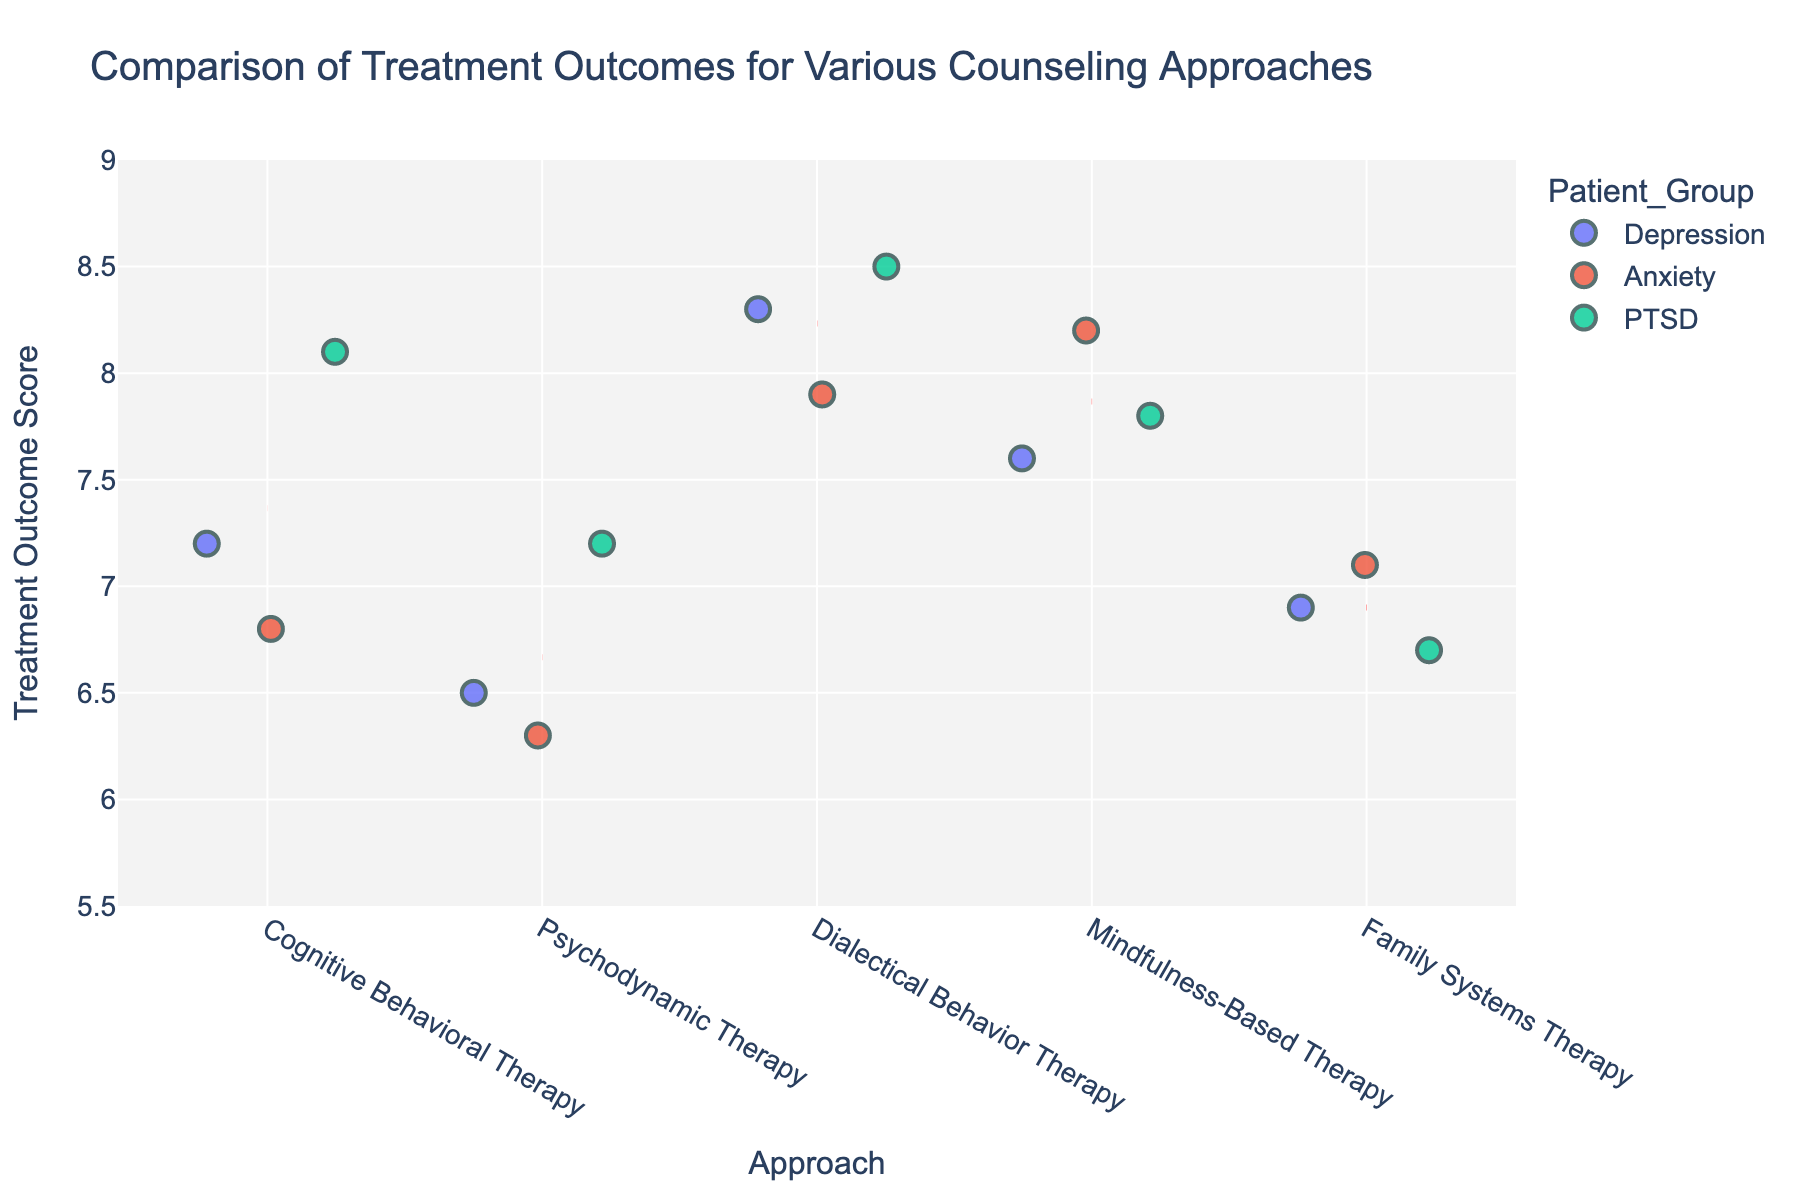What is the title of the figure? The title is shown at the top of the figure. It states the main theme or subject of the plot.
Answer: Comparison of Treatment Outcomes for Various Counseling Approaches How many different counseling approaches are compared in the figure? Each unique category on the x-axis (Approach) represents a different counseling approach.
Answer: 5 Which counseling approach has the highest treatment outcome score for PTSD patients? By looking at the y-axis values and filtering for PTSD (indicated by different colors), the highest point for PTSD aligns with Dialectical Behavior Therapy.
Answer: Dialectical Behavior Therapy What is the approximate average treatment outcome score for Cognitive Behavioral Therapy? To find the average, identify the scores for Cognitive Behavioral Therapy on the y-axis, then compute the mean: (7.2 + 6.8 + 8.1)/3.
Answer: 7.37 Which patient group generally shows the highest treatment outcome score across all approaches? By observing the placement of colors representing different patient groups along the y-axis, Anxiety scores are generally higher across multiple approaches.
Answer: Anxiety How does the average outcome score for Psychodynamic Therapy compare to Dialectical Behavior Therapy? Calculate the average for each approach: Psychodynamic Therapy (6.5, 6.3, 7.2) ≈ 6.67, Dialectical Behavior Therapy (8.3, 7.9, 8.5) ≈ 8.23. Compare their averages.
Answer: Dialectical Behavior Therapy has a higher average What is the range of treatment outcome scores for Family Systems Therapy? Identify the minimum and maximum points for Family Systems Therapy on the y-axis. The range is the difference between these values: max 7.1, min 6.7.
Answer: 6.7 to 7.1 Are there any counseling approaches where the mean outcome score is below 7? If so, which? Look for red dashed lines (mean scores) on the figure and assess which approach's mean score lies below 7. This comparison indicates that both Psychodynamic Therapy and Family Systems Therapy satisfy this condition.
Answer: Psychodynamic Therapy, Family Systems Therapy Which patient group has the lowest outcome score within any counseling approach? Pinpoint the lowest point across all patient groups on the y-axis and note the corresponding group and approach. The lowest score (6.3) belongs to Anxiety in Psychodynamic Therapy.
Answer: Anxiety in Psychodynamic Therapy 